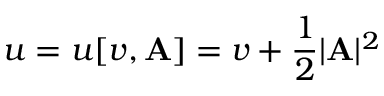<formula> <loc_0><loc_0><loc_500><loc_500>u = u [ v , A ] = v + \frac { 1 } { 2 } | A | ^ { 2 }</formula> 